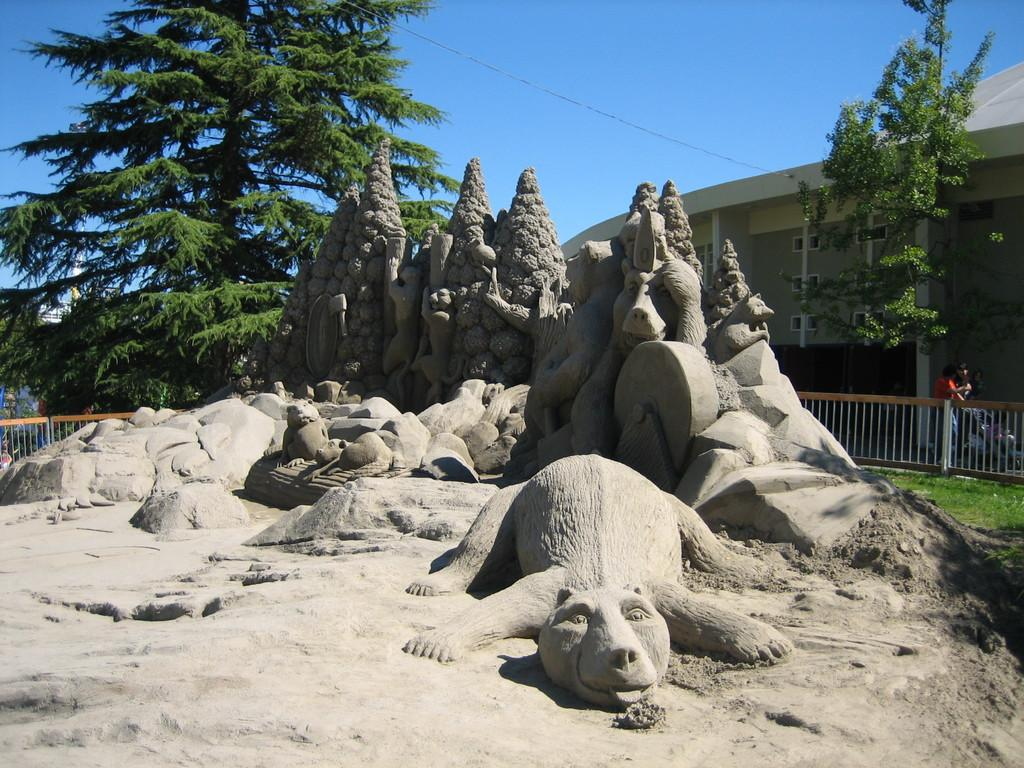What is the main subject of the image? There is a sand carving in the image. What can be seen in the background of the image? There are buildings, a fence, and trees in the background of the image. What is the color of the sky in the image? The sky is blue in the image. What type of locket is hanging from the sand carving? There is no locket present in the image; it features a sand carving. 